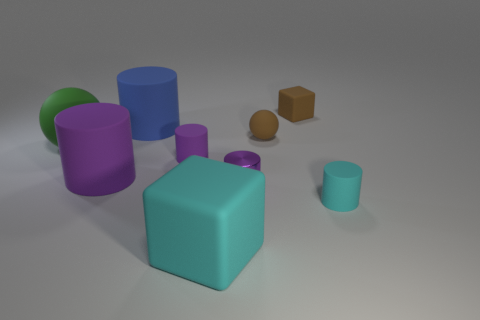Subtract all purple blocks. How many purple cylinders are left? 3 Subtract all blue cylinders. How many cylinders are left? 4 Subtract all tiny cyan matte cylinders. How many cylinders are left? 4 Subtract 3 cylinders. How many cylinders are left? 2 Add 1 large green balls. How many objects exist? 10 Subtract all cyan cylinders. Subtract all purple cubes. How many cylinders are left? 4 Subtract all balls. How many objects are left? 7 Add 1 large cylinders. How many large cylinders are left? 3 Add 6 small blocks. How many small blocks exist? 7 Subtract 0 purple blocks. How many objects are left? 9 